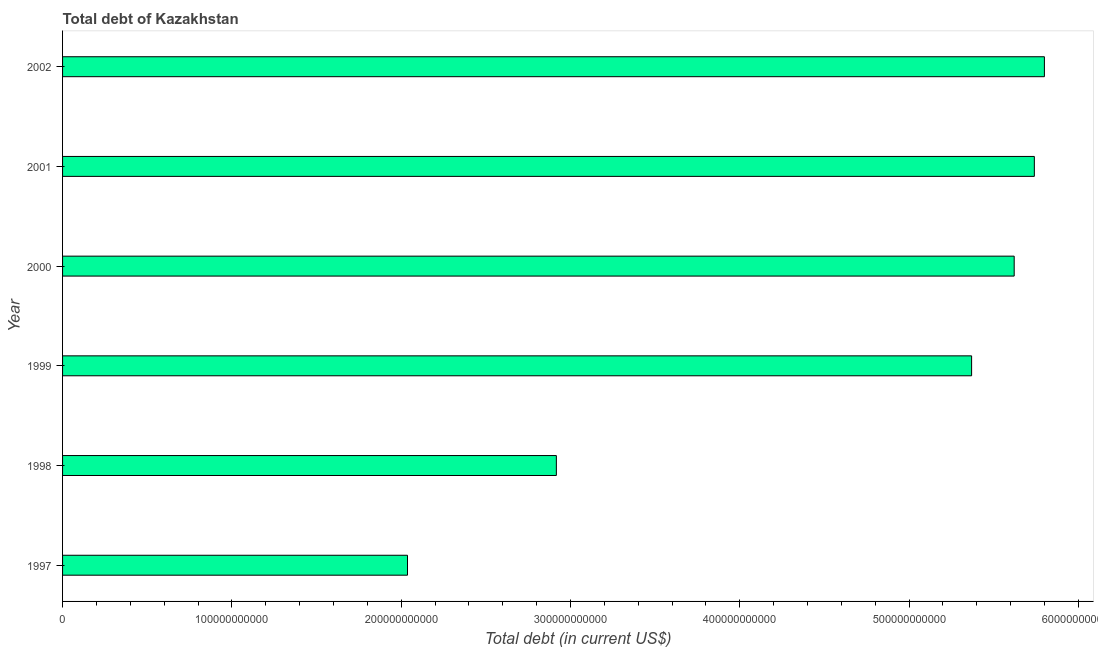Does the graph contain grids?
Give a very brief answer. No. What is the title of the graph?
Make the answer very short. Total debt of Kazakhstan. What is the label or title of the X-axis?
Keep it short and to the point. Total debt (in current US$). What is the total debt in 2002?
Provide a succinct answer. 5.80e+11. Across all years, what is the maximum total debt?
Make the answer very short. 5.80e+11. Across all years, what is the minimum total debt?
Ensure brevity in your answer.  2.04e+11. In which year was the total debt maximum?
Your response must be concise. 2002. In which year was the total debt minimum?
Your answer should be very brief. 1997. What is the sum of the total debt?
Your response must be concise. 2.75e+12. What is the difference between the total debt in 1999 and 2000?
Provide a short and direct response. -2.51e+1. What is the average total debt per year?
Give a very brief answer. 4.58e+11. What is the median total debt?
Offer a terse response. 5.49e+11. What is the ratio of the total debt in 1997 to that in 2001?
Keep it short and to the point. 0.35. What is the difference between the highest and the second highest total debt?
Your response must be concise. 5.94e+09. Is the sum of the total debt in 1999 and 2000 greater than the maximum total debt across all years?
Your response must be concise. Yes. What is the difference between the highest and the lowest total debt?
Provide a short and direct response. 3.76e+11. In how many years, is the total debt greater than the average total debt taken over all years?
Your answer should be very brief. 4. How many bars are there?
Keep it short and to the point. 6. What is the difference between two consecutive major ticks on the X-axis?
Offer a terse response. 1.00e+11. What is the Total debt (in current US$) of 1997?
Give a very brief answer. 2.04e+11. What is the Total debt (in current US$) in 1998?
Give a very brief answer. 2.92e+11. What is the Total debt (in current US$) of 1999?
Offer a terse response. 5.37e+11. What is the Total debt (in current US$) of 2000?
Your response must be concise. 5.62e+11. What is the Total debt (in current US$) of 2001?
Provide a succinct answer. 5.74e+11. What is the Total debt (in current US$) in 2002?
Provide a short and direct response. 5.80e+11. What is the difference between the Total debt (in current US$) in 1997 and 1998?
Provide a short and direct response. -8.79e+1. What is the difference between the Total debt (in current US$) in 1997 and 1999?
Provide a short and direct response. -3.33e+11. What is the difference between the Total debt (in current US$) in 1997 and 2000?
Keep it short and to the point. -3.58e+11. What is the difference between the Total debt (in current US$) in 1997 and 2001?
Your answer should be very brief. -3.70e+11. What is the difference between the Total debt (in current US$) in 1997 and 2002?
Provide a succinct answer. -3.76e+11. What is the difference between the Total debt (in current US$) in 1998 and 1999?
Your answer should be very brief. -2.45e+11. What is the difference between the Total debt (in current US$) in 1998 and 2000?
Provide a succinct answer. -2.70e+11. What is the difference between the Total debt (in current US$) in 1998 and 2001?
Ensure brevity in your answer.  -2.82e+11. What is the difference between the Total debt (in current US$) in 1998 and 2002?
Offer a very short reply. -2.88e+11. What is the difference between the Total debt (in current US$) in 1999 and 2000?
Your answer should be very brief. -2.51e+1. What is the difference between the Total debt (in current US$) in 1999 and 2001?
Your answer should be very brief. -3.70e+1. What is the difference between the Total debt (in current US$) in 1999 and 2002?
Your response must be concise. -4.30e+1. What is the difference between the Total debt (in current US$) in 2000 and 2001?
Your answer should be compact. -1.19e+1. What is the difference between the Total debt (in current US$) in 2000 and 2002?
Offer a terse response. -1.78e+1. What is the difference between the Total debt (in current US$) in 2001 and 2002?
Offer a very short reply. -5.94e+09. What is the ratio of the Total debt (in current US$) in 1997 to that in 1998?
Your answer should be compact. 0.7. What is the ratio of the Total debt (in current US$) in 1997 to that in 1999?
Give a very brief answer. 0.38. What is the ratio of the Total debt (in current US$) in 1997 to that in 2000?
Give a very brief answer. 0.36. What is the ratio of the Total debt (in current US$) in 1997 to that in 2001?
Your answer should be compact. 0.35. What is the ratio of the Total debt (in current US$) in 1997 to that in 2002?
Offer a terse response. 0.35. What is the ratio of the Total debt (in current US$) in 1998 to that in 1999?
Your answer should be very brief. 0.54. What is the ratio of the Total debt (in current US$) in 1998 to that in 2000?
Your answer should be very brief. 0.52. What is the ratio of the Total debt (in current US$) in 1998 to that in 2001?
Offer a terse response. 0.51. What is the ratio of the Total debt (in current US$) in 1998 to that in 2002?
Offer a very short reply. 0.5. What is the ratio of the Total debt (in current US$) in 1999 to that in 2000?
Make the answer very short. 0.95. What is the ratio of the Total debt (in current US$) in 1999 to that in 2001?
Offer a terse response. 0.94. What is the ratio of the Total debt (in current US$) in 1999 to that in 2002?
Ensure brevity in your answer.  0.93. What is the ratio of the Total debt (in current US$) in 2001 to that in 2002?
Give a very brief answer. 0.99. 